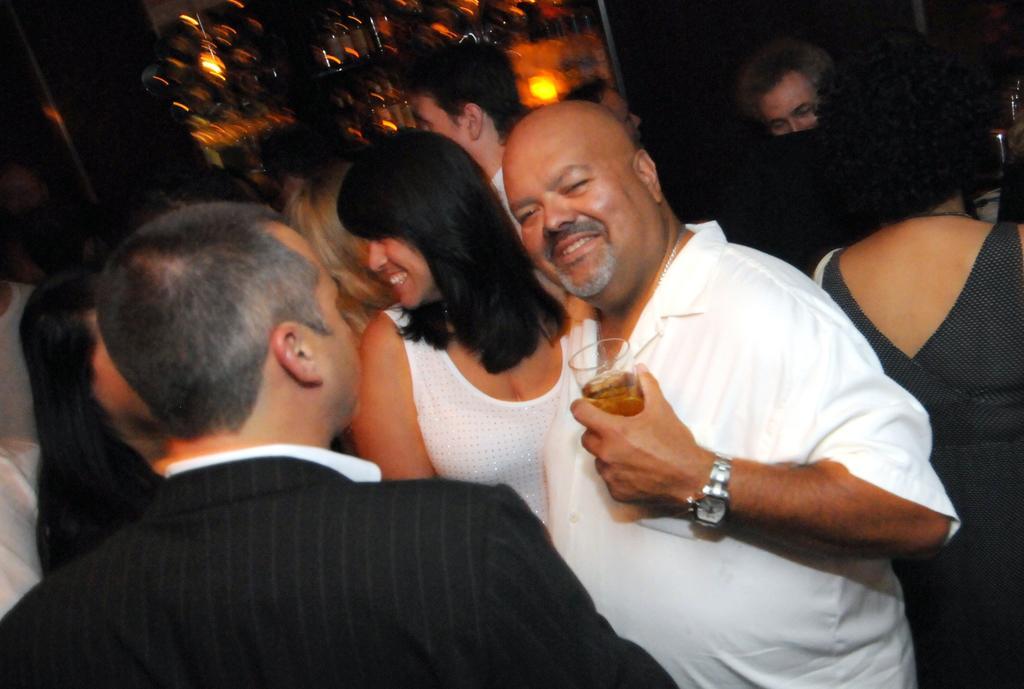Could you give a brief overview of what you see in this image? In this image we can see people. The man standing in the center is holding a wine glass. In the background there are lights. 